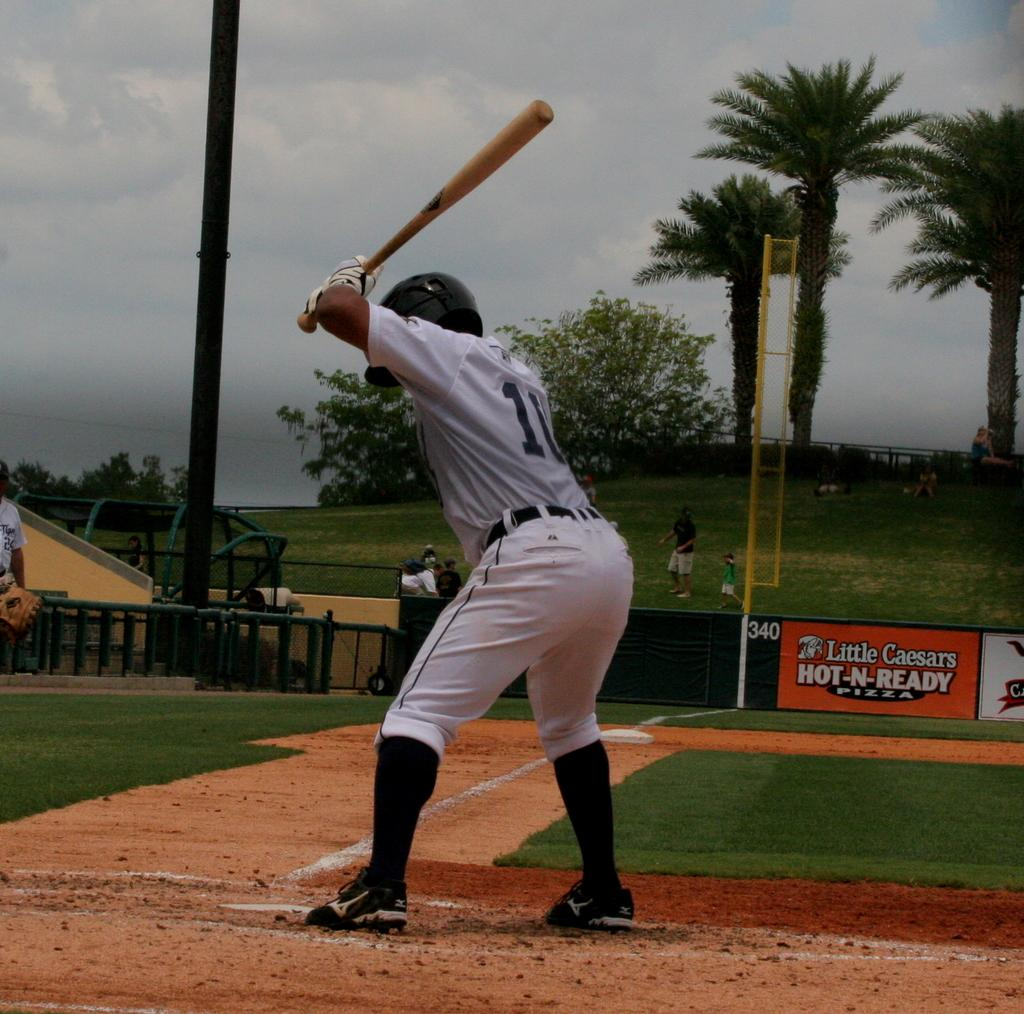Provide a one-sentence caption for the provided image. At this baseball pitch, Little Caesars Pizzas are advertised. 